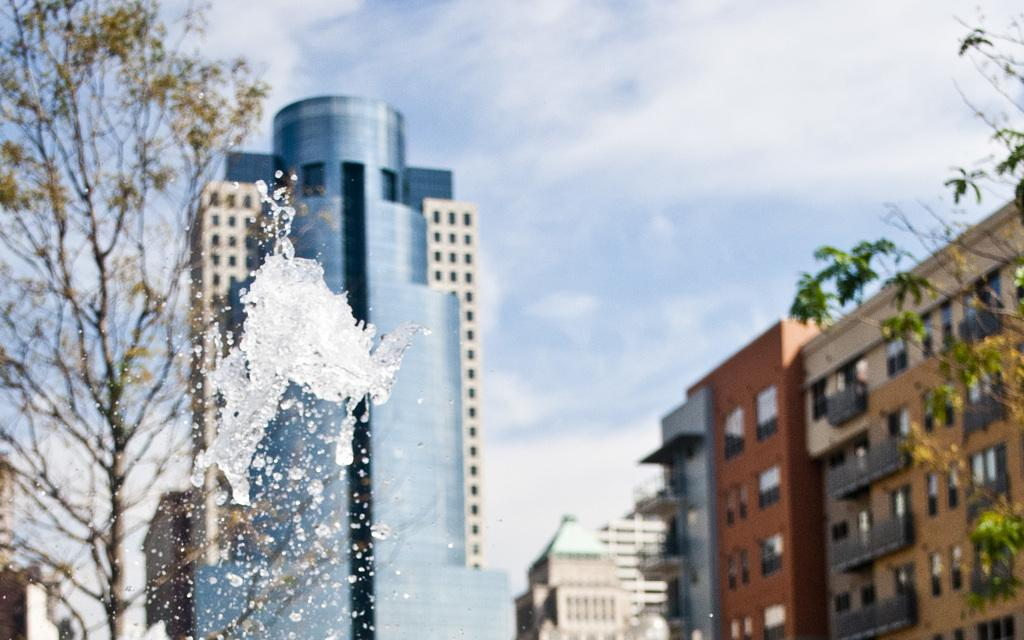What is the main feature in the middle of the image? There is a splash of water in the middle of the image. What can be seen in the background of the image? There are buildings in the background of the image. What is visible at the top of the image? The sky is visible at the top of the image. What type of vegetation is on the left side of the image? There is a tree on the left side of the image. Can you see an airplane flying in the image? There is no airplane visible in the image. What type of plane is being used to wash the tree in the image? There is no plane or washing activity present in the image. 